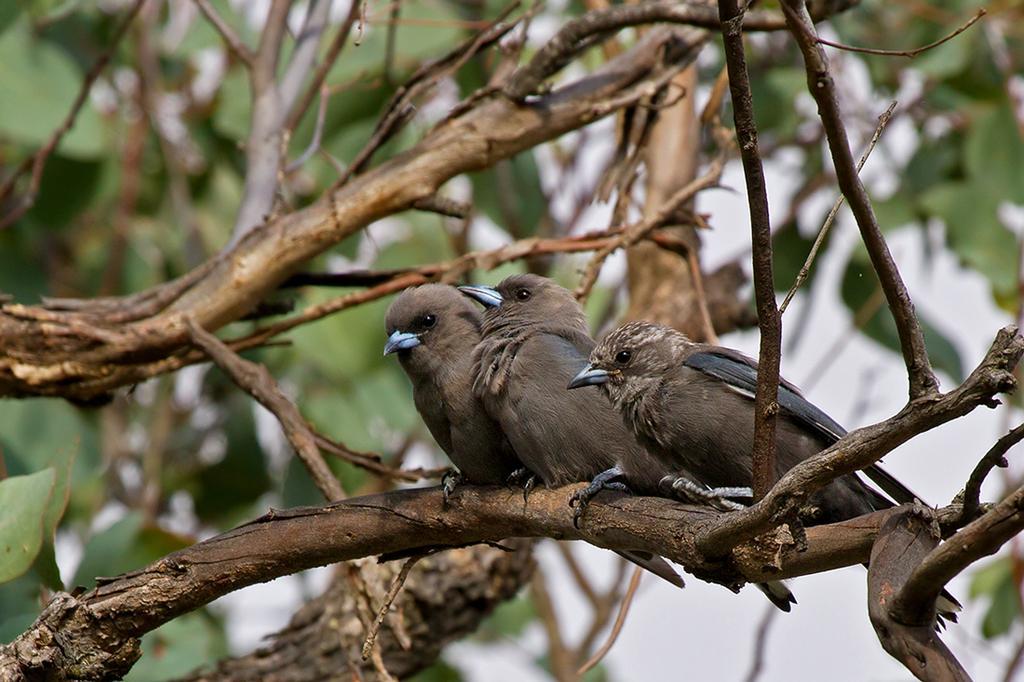How would you summarize this image in a sentence or two? In the foreground of the picture there are stems of a tree. In the center of the picture there are three birds sitting on the stem. The background is blurred. In the background there is greenery. 